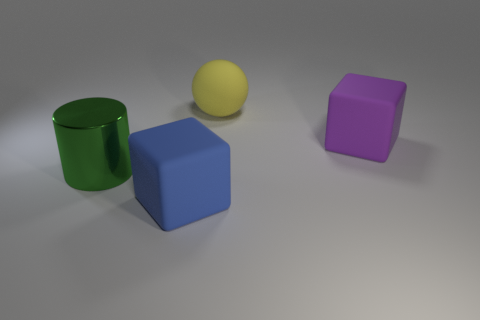There is a big blue object; is it the same shape as the big matte object that is on the right side of the yellow matte ball?
Your answer should be compact. Yes. There is a object on the right side of the yellow thing; does it have the same shape as the big blue matte thing?
Offer a terse response. Yes. Is there another object of the same shape as the purple object?
Keep it short and to the point. Yes. There is another large block that is the same material as the purple cube; what is its color?
Offer a terse response. Blue. How many objects are big green metallic cylinders or large purple things?
Your response must be concise. 2. What is the shape of the purple thing that is the same size as the rubber ball?
Your answer should be compact. Cube. What number of large objects are to the right of the blue thing and in front of the yellow ball?
Your answer should be very brief. 1. There is a green object in front of the large purple rubber cube; what is its material?
Keep it short and to the point. Metal. There is a blue object that is made of the same material as the large sphere; what is its size?
Provide a succinct answer. Large. What material is the purple thing that is the same size as the matte ball?
Your response must be concise. Rubber. 